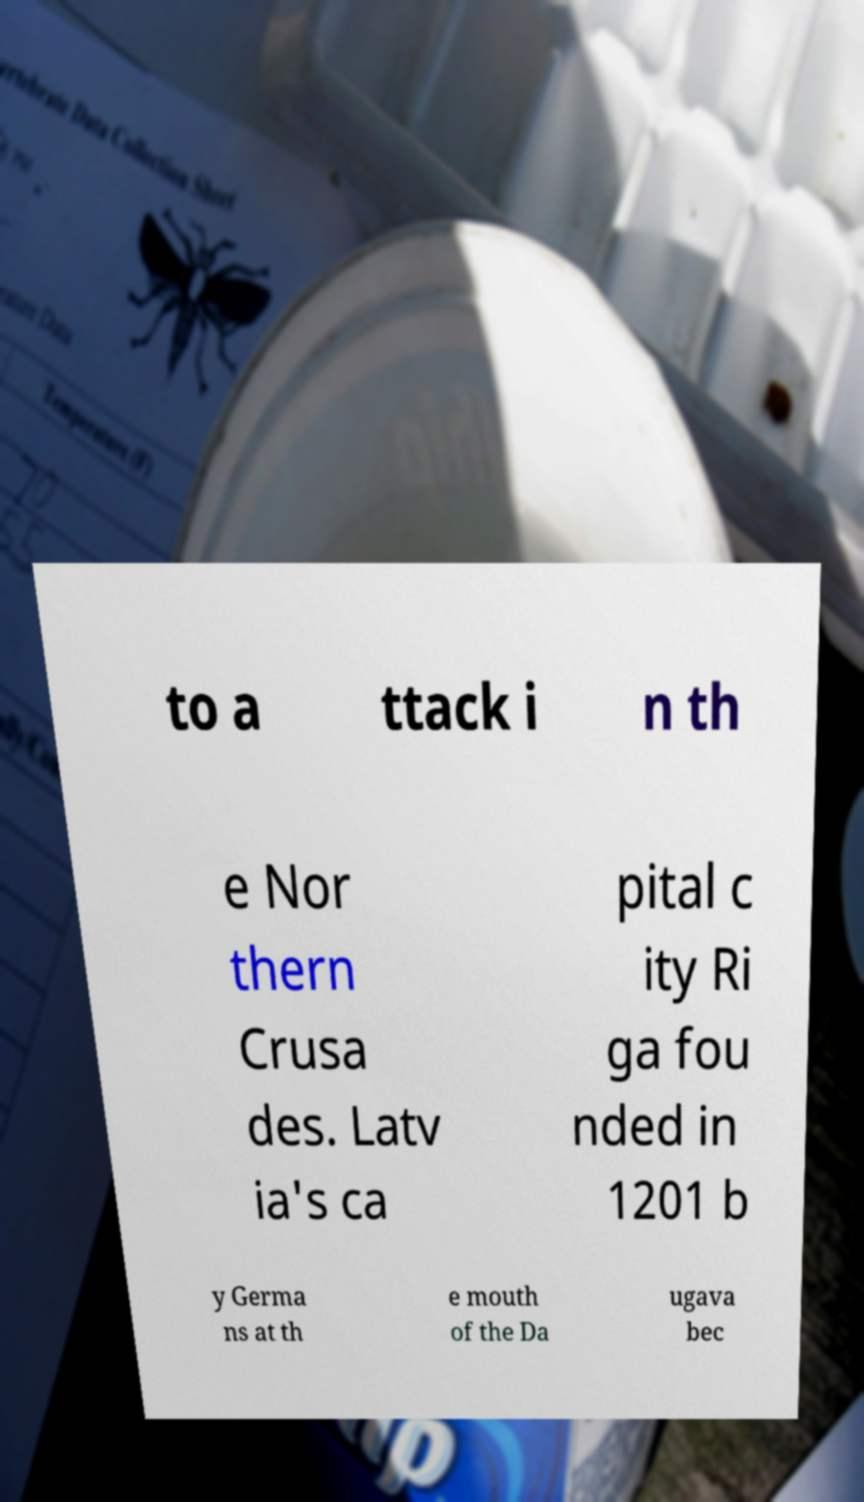Could you assist in decoding the text presented in this image and type it out clearly? to a ttack i n th e Nor thern Crusa des. Latv ia's ca pital c ity Ri ga fou nded in 1201 b y Germa ns at th e mouth of the Da ugava bec 